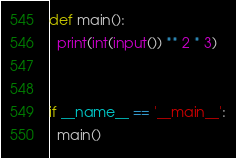Convert code to text. <code><loc_0><loc_0><loc_500><loc_500><_Python_>def main():
  print(int(input()) ** 2 * 3)


if __name__ == '__main__':
  main()
</code> 